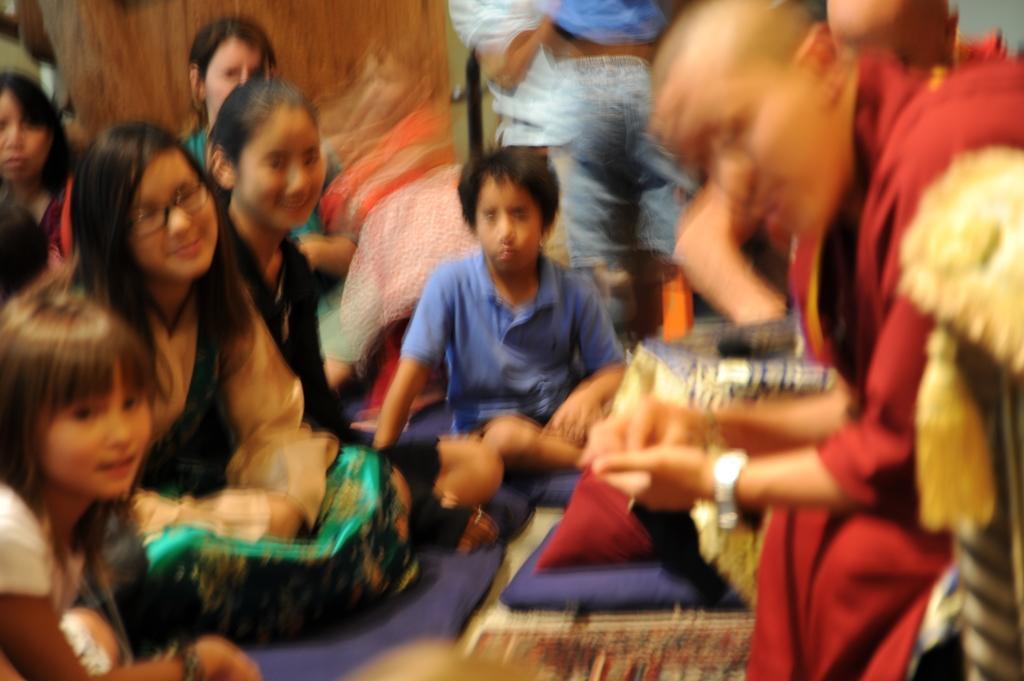In one or two sentences, can you explain what this image depicts? In this image we can see people sitting and standing on the floor. 